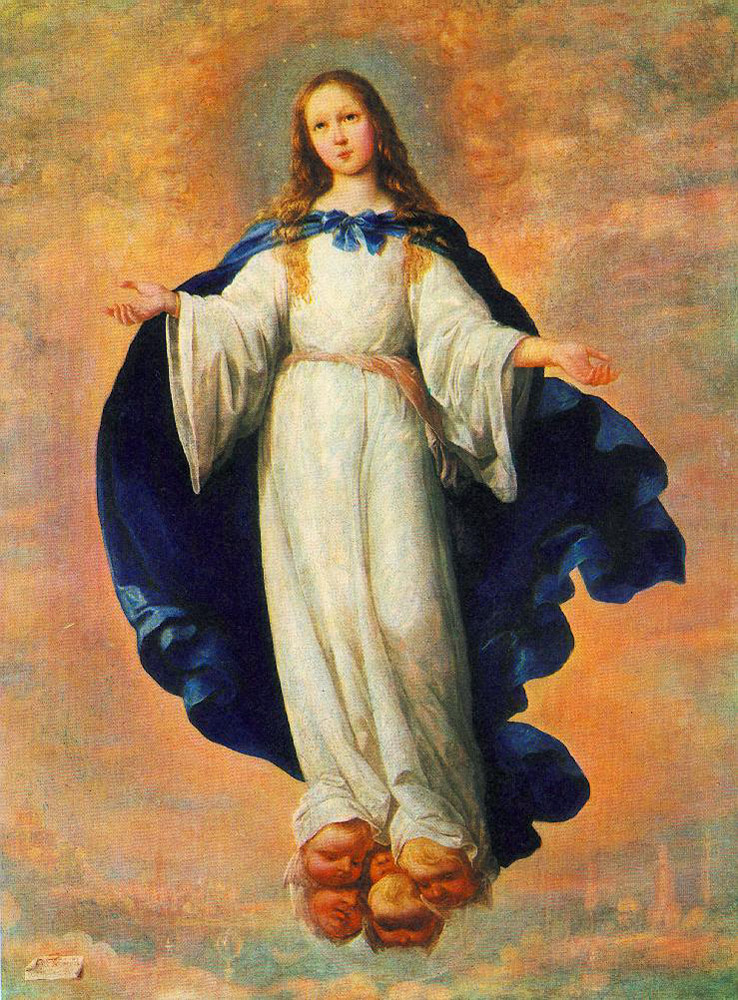What emotion does the artist seem to convey through the girl's expression and posture? The artist conveys a sense of serene calmness and benevolence through the girl's expression and posture. Her facial expression is gentle and reassuring, and her open arms, extended gracefully, suggest an offering of peace or a welcoming gesture. This posture can be seen as a symbol of inclusivity and spiritual embrace, inviting contemplation on celestial peace and protection. Does the background play any role in enhancing these themes? Yes, the softly blurred cityscape set against a cloudy sky plays a crucial role in enhancing the painting's themes. By placing the celestial figure above the mundane world, the artist accentuates the idea of spiritual oversight or guardianship. The clouds not only add a dreamy, ethereal quality but also symbolize the boundary between the earthly and the divine, reinforcing the figure's role as a mediator or protector. 